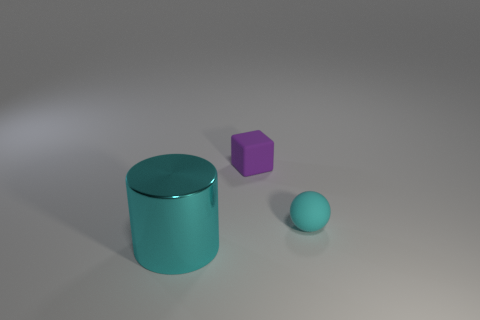Is the number of large cylinders that are in front of the metal cylinder greater than the number of matte things that are in front of the small matte sphere?
Your answer should be very brief. No. How many small things have the same color as the cylinder?
Ensure brevity in your answer.  1. What is the size of the cyan object that is the same material as the tiny purple cube?
Give a very brief answer. Small. What number of objects are small matte things that are left of the small cyan ball or large gray rubber balls?
Ensure brevity in your answer.  1. Is the color of the small matte object that is behind the small cyan thing the same as the cylinder?
Your answer should be very brief. No. What is the color of the tiny thing to the right of the rubber object behind the thing right of the purple matte cube?
Offer a terse response. Cyan. Do the large cylinder and the tiny ball have the same material?
Keep it short and to the point. No. Are there any cyan objects that are left of the tiny thing that is behind the small object that is in front of the small purple cube?
Give a very brief answer. Yes. Do the large metallic object and the tiny sphere have the same color?
Ensure brevity in your answer.  Yes. Is the number of purple blocks less than the number of large purple objects?
Offer a terse response. No. 